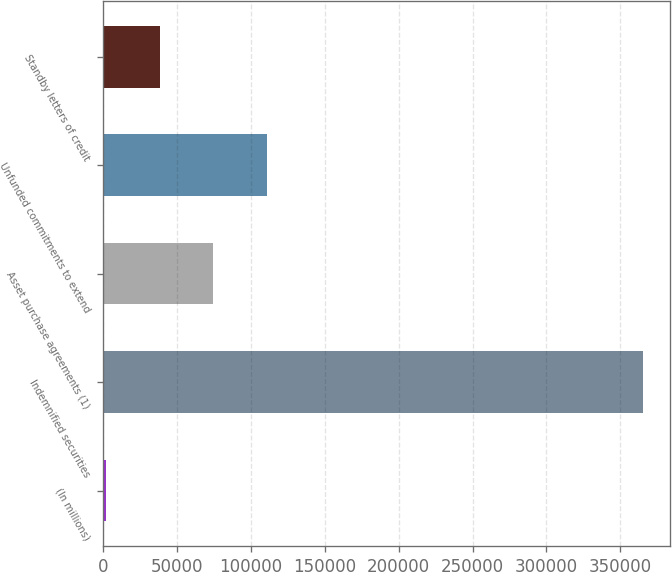Convert chart to OTSL. <chart><loc_0><loc_0><loc_500><loc_500><bar_chart><fcel>(In millions)<fcel>Indemnified securities<fcel>Asset purchase agreements (1)<fcel>Unfunded commitments to extend<fcel>Standby letters of credit<nl><fcel>2009<fcel>365251<fcel>74657.4<fcel>110982<fcel>38333.2<nl></chart> 